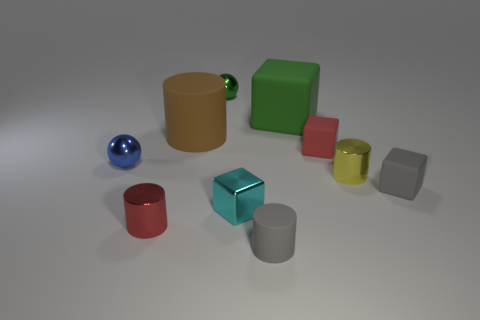Is the size of the green rubber cube the same as the yellow cylinder? no 